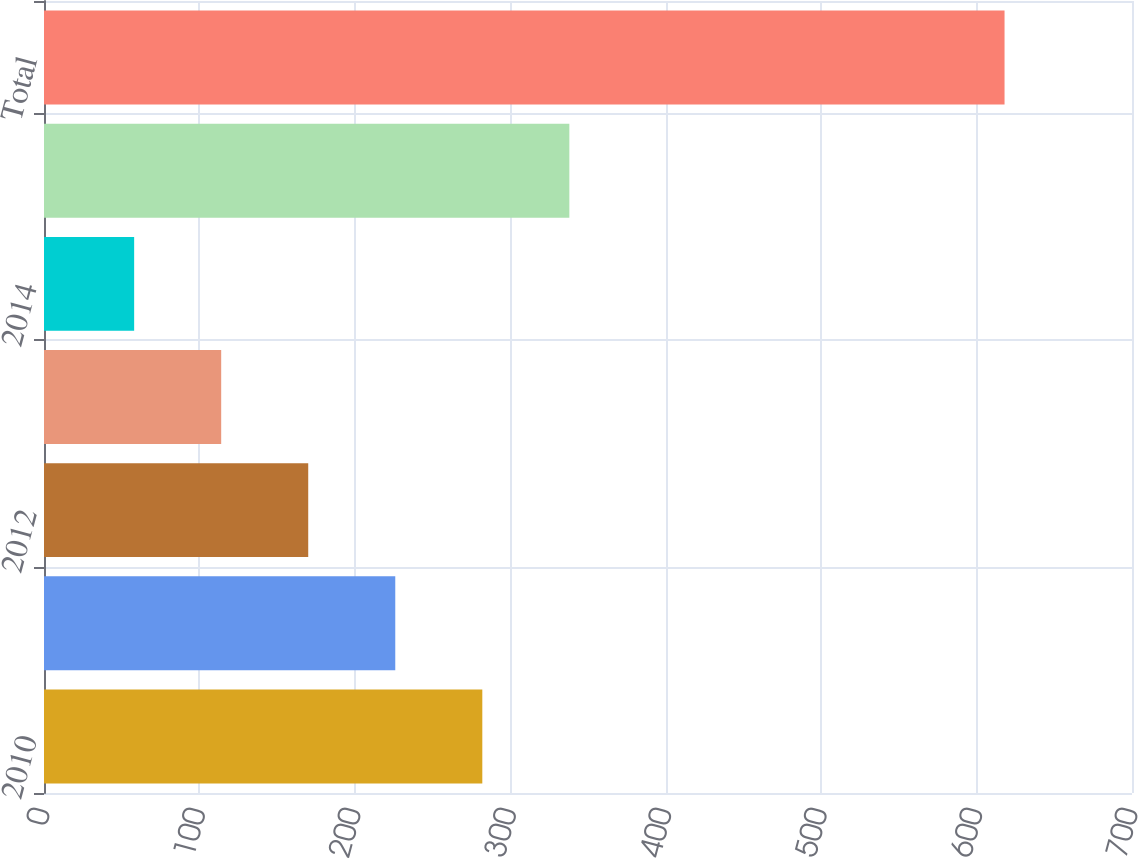<chart> <loc_0><loc_0><loc_500><loc_500><bar_chart><fcel>2010<fcel>2011<fcel>2012<fcel>2013<fcel>2014<fcel>Thereafter<fcel>Total<nl><fcel>282<fcel>226<fcel>170<fcel>114<fcel>58<fcel>338<fcel>618<nl></chart> 